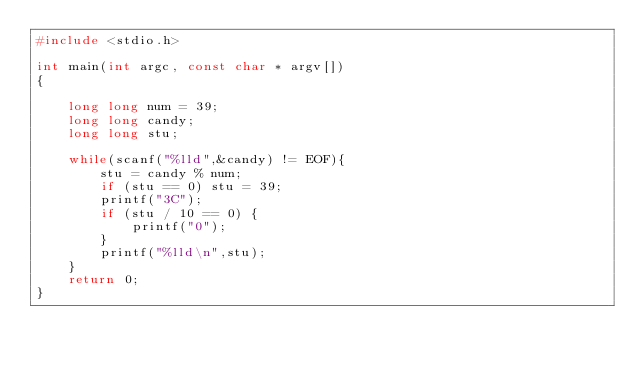<code> <loc_0><loc_0><loc_500><loc_500><_C_>#include <stdio.h>

int main(int argc, const char * argv[])
{

    long long num = 39;
    long long candy;
    long long stu;
    
    while(scanf("%lld",&candy) != EOF){
        stu = candy % num;
        if (stu == 0) stu = 39;
        printf("3C");
        if (stu / 10 == 0) {
            printf("0");
        }
        printf("%lld\n",stu);
    }
    return 0;
}</code> 